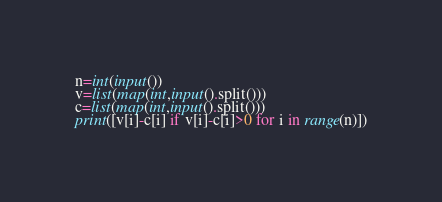<code> <loc_0><loc_0><loc_500><loc_500><_Python_>n=int(input())
v=list(map(int,input().split()))
c=list(map(int,input().split()))
print([v[i]-c[i] if v[i]-c[i]>0 for i in range(n)])</code> 